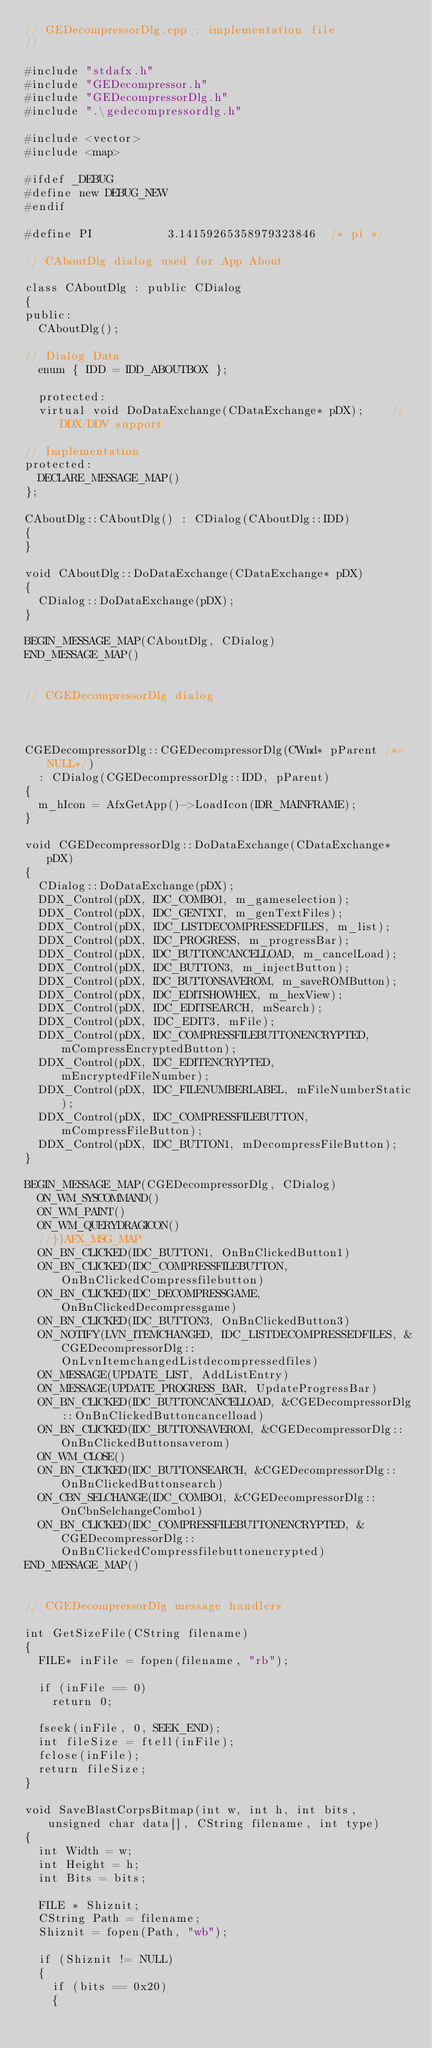Convert code to text. <code><loc_0><loc_0><loc_500><loc_500><_C++_>// GEDecompressorDlg.cpp : implementation file
//

#include "stdafx.h"
#include "GEDecompressor.h"
#include "GEDecompressorDlg.h"
#include ".\gedecompressordlg.h"

#include <vector>
#include <map>

#ifdef _DEBUG
#define new DEBUG_NEW
#endif

#define PI           3.14159265358979323846  /* pi */

// CAboutDlg dialog used for App About

class CAboutDlg : public CDialog
{
public:
	CAboutDlg();

// Dialog Data
	enum { IDD = IDD_ABOUTBOX };

	protected:
	virtual void DoDataExchange(CDataExchange* pDX);    // DDX/DDV support

// Implementation
protected:
	DECLARE_MESSAGE_MAP()
};

CAboutDlg::CAboutDlg() : CDialog(CAboutDlg::IDD)
{
}

void CAboutDlg::DoDataExchange(CDataExchange* pDX)
{
	CDialog::DoDataExchange(pDX);
}

BEGIN_MESSAGE_MAP(CAboutDlg, CDialog)
END_MESSAGE_MAP()


// CGEDecompressorDlg dialog



CGEDecompressorDlg::CGEDecompressorDlg(CWnd* pParent /*=NULL*/)
	: CDialog(CGEDecompressorDlg::IDD, pParent)
{
	m_hIcon = AfxGetApp()->LoadIcon(IDR_MAINFRAME);
}

void CGEDecompressorDlg::DoDataExchange(CDataExchange* pDX)
{
	CDialog::DoDataExchange(pDX);
	DDX_Control(pDX, IDC_COMBO1, m_gameselection);
	DDX_Control(pDX, IDC_GENTXT, m_genTextFiles);
	DDX_Control(pDX, IDC_LISTDECOMPRESSEDFILES, m_list);
	DDX_Control(pDX, IDC_PROGRESS, m_progressBar);
	DDX_Control(pDX, IDC_BUTTONCANCELLOAD, m_cancelLoad);
	DDX_Control(pDX, IDC_BUTTON3, m_injectButton);
	DDX_Control(pDX, IDC_BUTTONSAVEROM, m_saveROMButton);
	DDX_Control(pDX, IDC_EDITSHOWHEX, m_hexView);
	DDX_Control(pDX, IDC_EDITSEARCH, mSearch);
	DDX_Control(pDX, IDC_EDIT3, mFile);
	DDX_Control(pDX, IDC_COMPRESSFILEBUTTONENCRYPTED, mCompressEncryptedButton);
	DDX_Control(pDX, IDC_EDITENCRYPTED, mEncryptedFileNumber);
	DDX_Control(pDX, IDC_FILENUMBERLABEL, mFileNumberStatic);
	DDX_Control(pDX, IDC_COMPRESSFILEBUTTON, mCompressFileButton);
	DDX_Control(pDX, IDC_BUTTON1, mDecompressFileButton);
}

BEGIN_MESSAGE_MAP(CGEDecompressorDlg, CDialog)
	ON_WM_SYSCOMMAND()
	ON_WM_PAINT()
	ON_WM_QUERYDRAGICON()
	//}}AFX_MSG_MAP
	ON_BN_CLICKED(IDC_BUTTON1, OnBnClickedButton1)
	ON_BN_CLICKED(IDC_COMPRESSFILEBUTTON, OnBnClickedCompressfilebutton)
	ON_BN_CLICKED(IDC_DECOMPRESSGAME, OnBnClickedDecompressgame)
	ON_BN_CLICKED(IDC_BUTTON3, OnBnClickedButton3)
	ON_NOTIFY(LVN_ITEMCHANGED, IDC_LISTDECOMPRESSEDFILES, &CGEDecompressorDlg::OnLvnItemchangedListdecompressedfiles)
	ON_MESSAGE(UPDATE_LIST, AddListEntry)
	ON_MESSAGE(UPDATE_PROGRESS_BAR, UpdateProgressBar)
	ON_BN_CLICKED(IDC_BUTTONCANCELLOAD, &CGEDecompressorDlg::OnBnClickedButtoncancelload)
	ON_BN_CLICKED(IDC_BUTTONSAVEROM, &CGEDecompressorDlg::OnBnClickedButtonsaverom)
	ON_WM_CLOSE()
	ON_BN_CLICKED(IDC_BUTTONSEARCH, &CGEDecompressorDlg::OnBnClickedButtonsearch)
	ON_CBN_SELCHANGE(IDC_COMBO1, &CGEDecompressorDlg::OnCbnSelchangeCombo1)
	ON_BN_CLICKED(IDC_COMPRESSFILEBUTTONENCRYPTED, &CGEDecompressorDlg::OnBnClickedCompressfilebuttonencrypted)
END_MESSAGE_MAP()


// CGEDecompressorDlg message handlers

int GetSizeFile(CString filename)
{
	FILE* inFile = fopen(filename, "rb");
	
	if (inFile == 0)
		return 0;

	fseek(inFile, 0, SEEK_END);
	int fileSize = ftell(inFile);
	fclose(inFile);
	return fileSize;
}

void SaveBlastCorpsBitmap(int w, int h, int bits, unsigned char data[], CString filename, int type)
{
	int Width = w;
	int Height = h;
	int Bits = bits;

	FILE * Shiznit;
	CString Path = filename;
	Shiznit = fopen(Path, "wb");

	if (Shiznit != NULL)
	{
		if (bits == 0x20)
		{</code> 